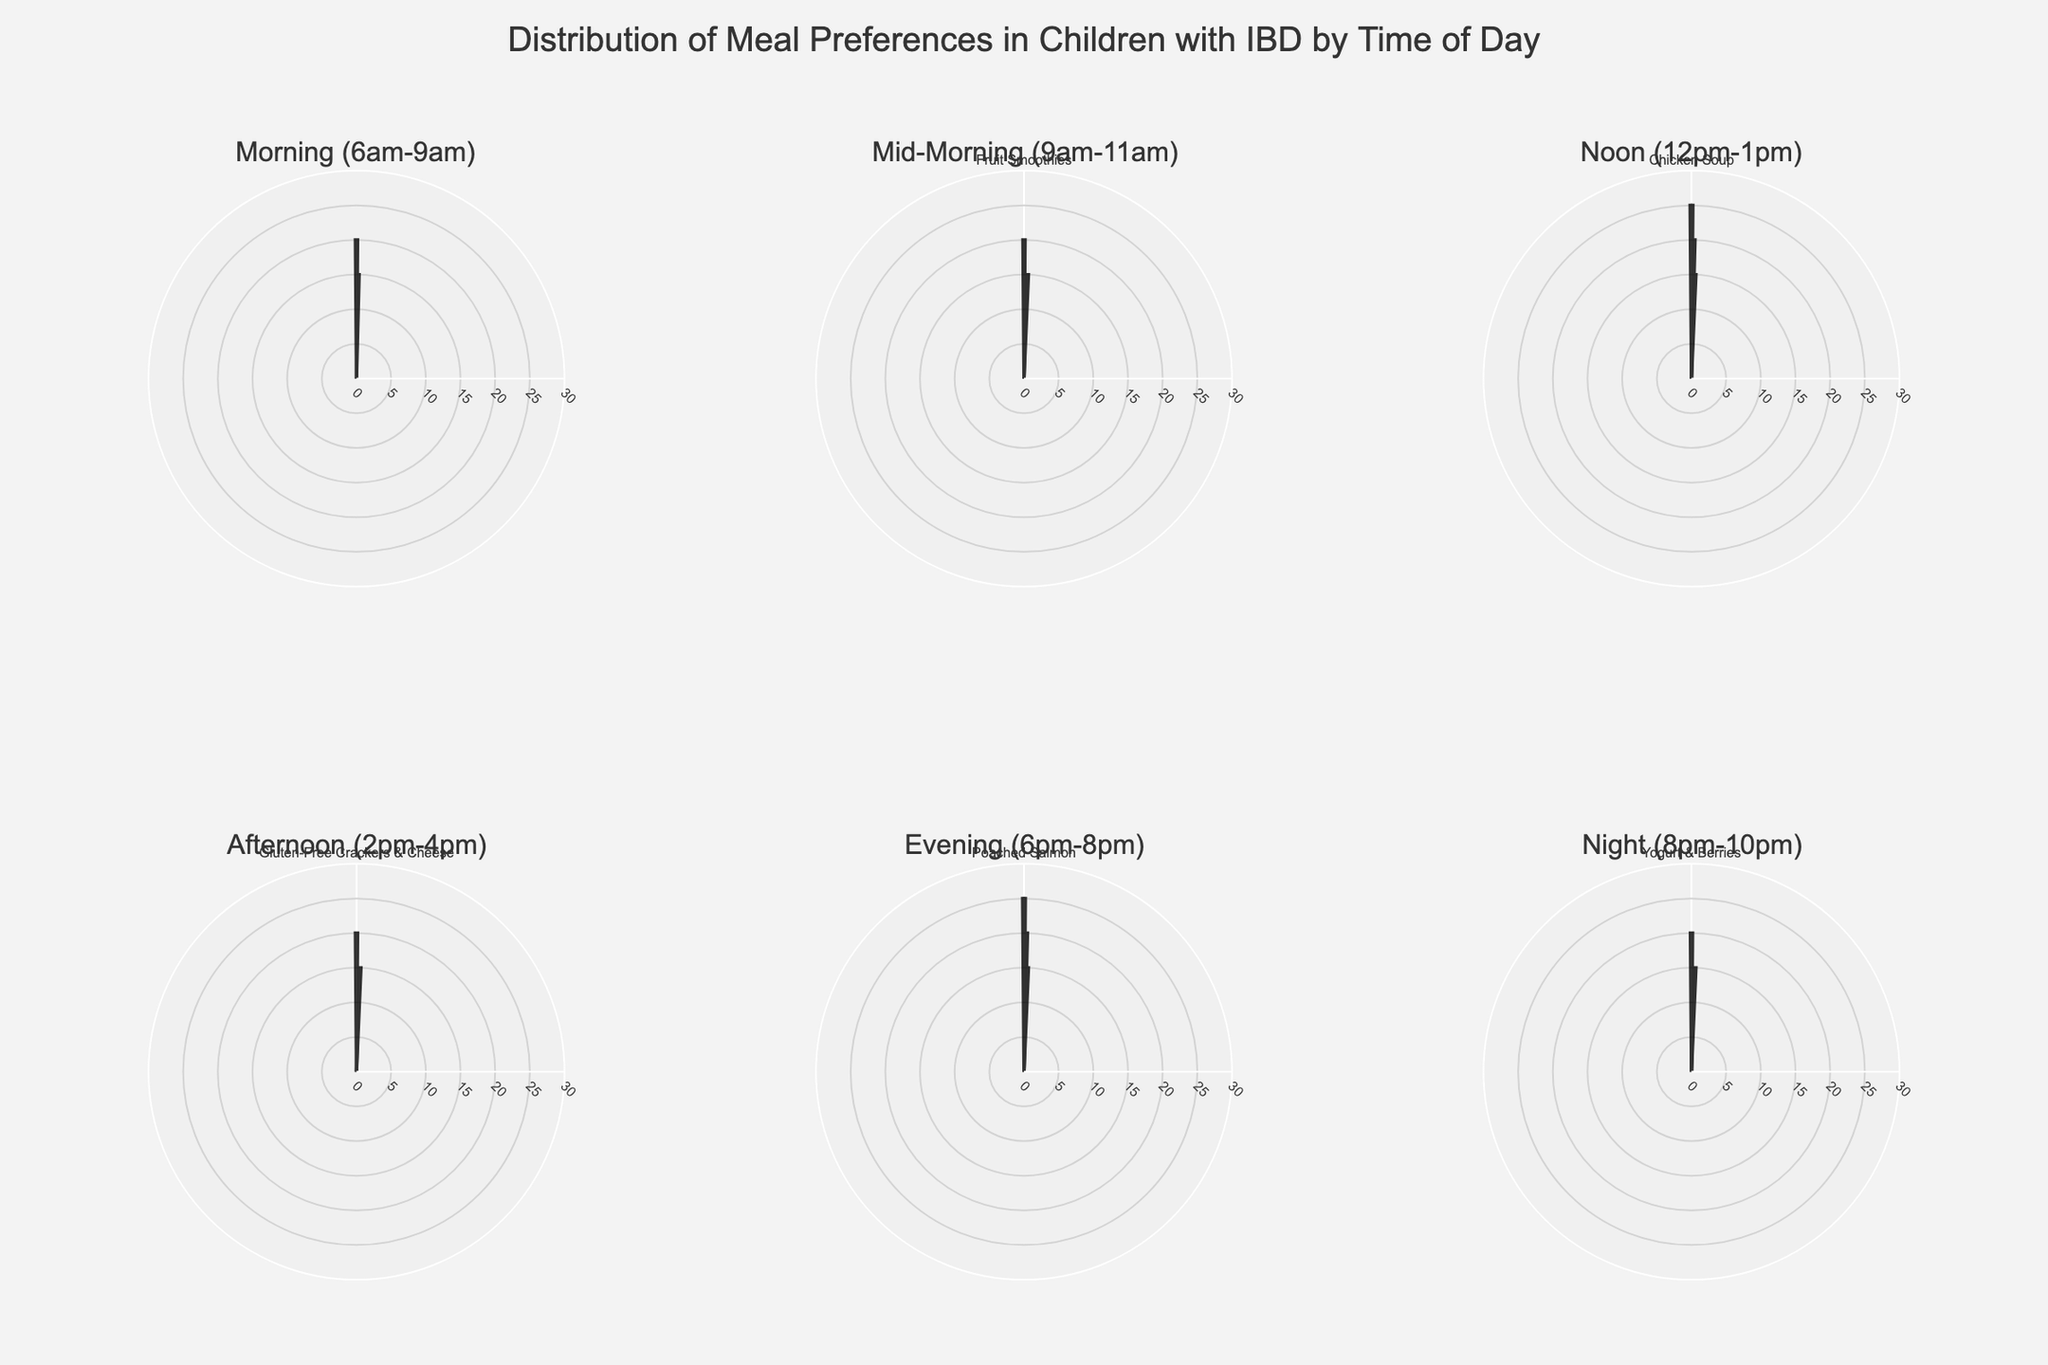What is the title of the figure? The title is usually displayed at the top of the figure. By reading it, you can get a summary description of what the figure represents.
Answer: Distribution of Meal Preferences in Children with IBD by Time of Day Which meal preference is most popular during lunch (Noon)? Look at the subplot for lunch (Noon (12pm-1pm)). Identify the meal with the highest percentage in this time segment.
Answer: Chicken Soup What percentage of children prefer yogurt & fruits in the morning (6am-9am)? Check the morning (6am-9am) subplot and find the segment labeled "Yogurt & Fruits". The percentage is given alongside the label.
Answer: 20% How does the preference for grilled chicken salad at noon compare to poached salmon in the evening? Compare the percentage for grilled chicken salad during noon (20%) with poached salmon during the evening (25%).
Answer: Poached Salmon is more preferred What is the least preferred snack during the night (8pm-10pm)? In the night (8pm-10pm) subplot, find the snack with the lowest percentage value.
Answer: Peanut Butter on Rice Cakes Which time of day has the highest variety of meal preferences? Count the different segments (meal options) in each subplot. The time of day with the most segments has the highest variety.
Answer: Mid-Morning (9am-11am) What is the combined percentage of children preferring chicken soup and grilled chicken salad at noon? Add the percentage of preferences for chicken soup (25%) and grilled chicken salad (20%) at noon. The combined percentage is 25 + 20 = 45.
Answer: 45% How does the preference for afternoon snacks compare to morning snacks? Compare the total number of snack preferences and their percentages in the morning (6am-9am) versus afternoon (2pm-4pm) subplots. Morning has only breakfast segments, so compare favorability based on similar meal type counts like snacks.
Answer: More variety in afternoon Is there any meal preference that appears in more than one time slot? Look through each subplot to find any meal preference that is repeated across different times of the day.
Answer: None What is the most preferred meal for dinner (6pm-8pm)? Look at the evening (6pm-8pm) subplot and identify the meal segment with the highest percentage.
Answer: Poached Salmon 